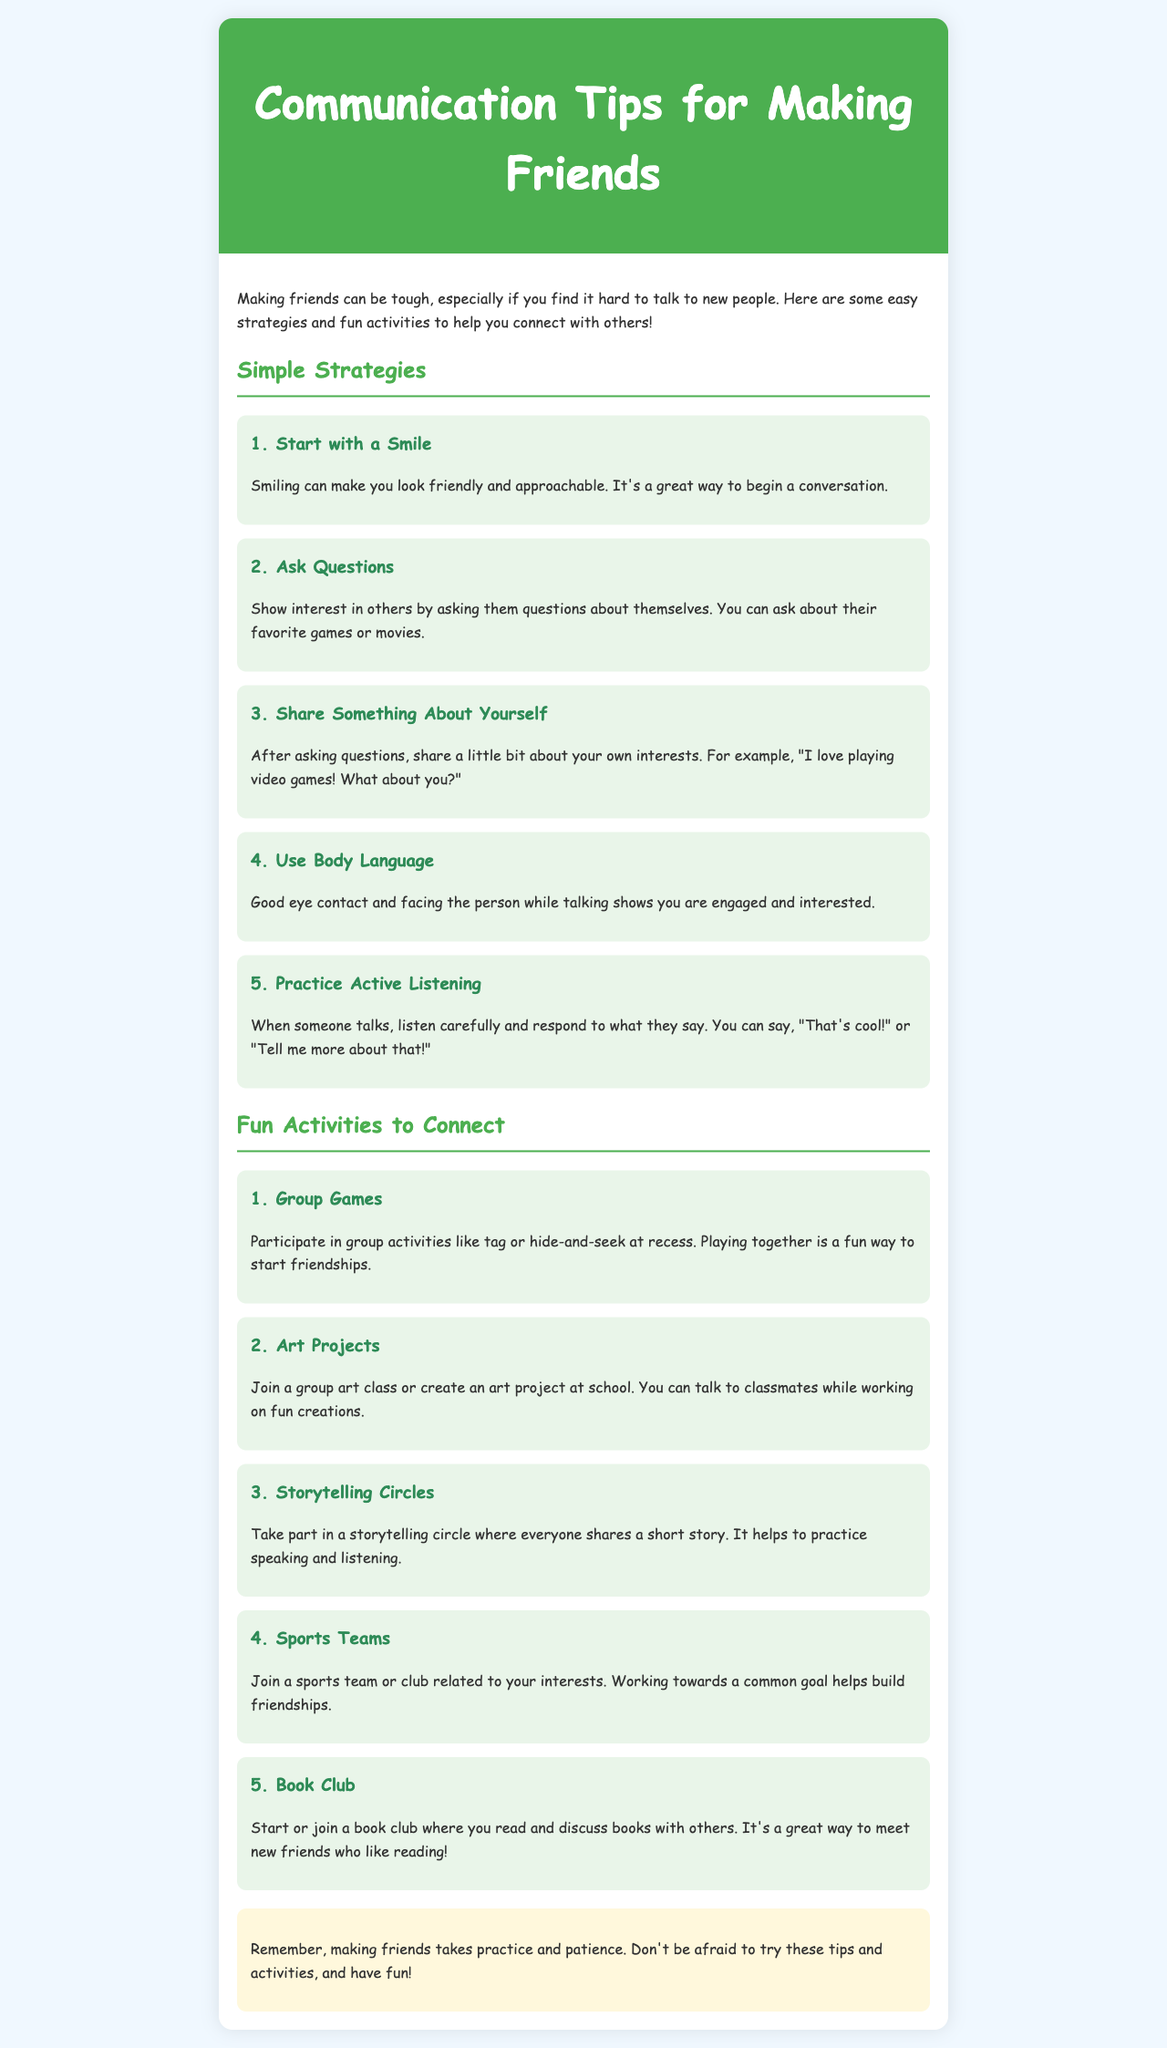What is the title of the newsletter? The title is stated at the top of the document in the header section.
Answer: Communication Tips for Making Friends What is the first strategy mentioned? The first strategy is found in the section titled "Simple Strategies."
Answer: Start with a Smile How many fun activities are listed? The number of activities is indicated in the "Fun Activities to Connect" section.
Answer: Five What is one example of a group game? An example of a group game can be found in the "Fun Activities to Connect" section.
Answer: Tag What should you do when someone talks? This guidance is provided in the "Practice Active Listening" tip in the document.
Answer: Listen carefully Why is body language important? The importance of body language is explained in the "Use Body Language" strategy.
Answer: Shows you are engaged What type of club is suggested for meeting friends? This information is found in the "Fun Activities to Connect" section under activities.
Answer: Book Club What color is used for the header background? The color of the header background is described in the style section of the document.
Answer: Green 